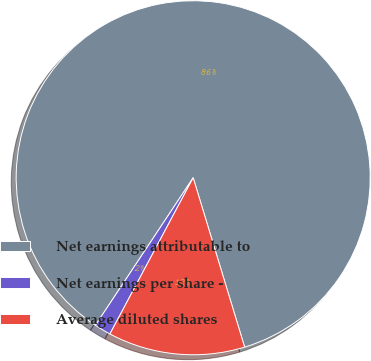<chart> <loc_0><loc_0><loc_500><loc_500><pie_chart><fcel>Net earnings attributable to<fcel>Net earnings per share -<fcel>Average diluted shares<nl><fcel>85.99%<fcel>1.52%<fcel>12.49%<nl></chart> 